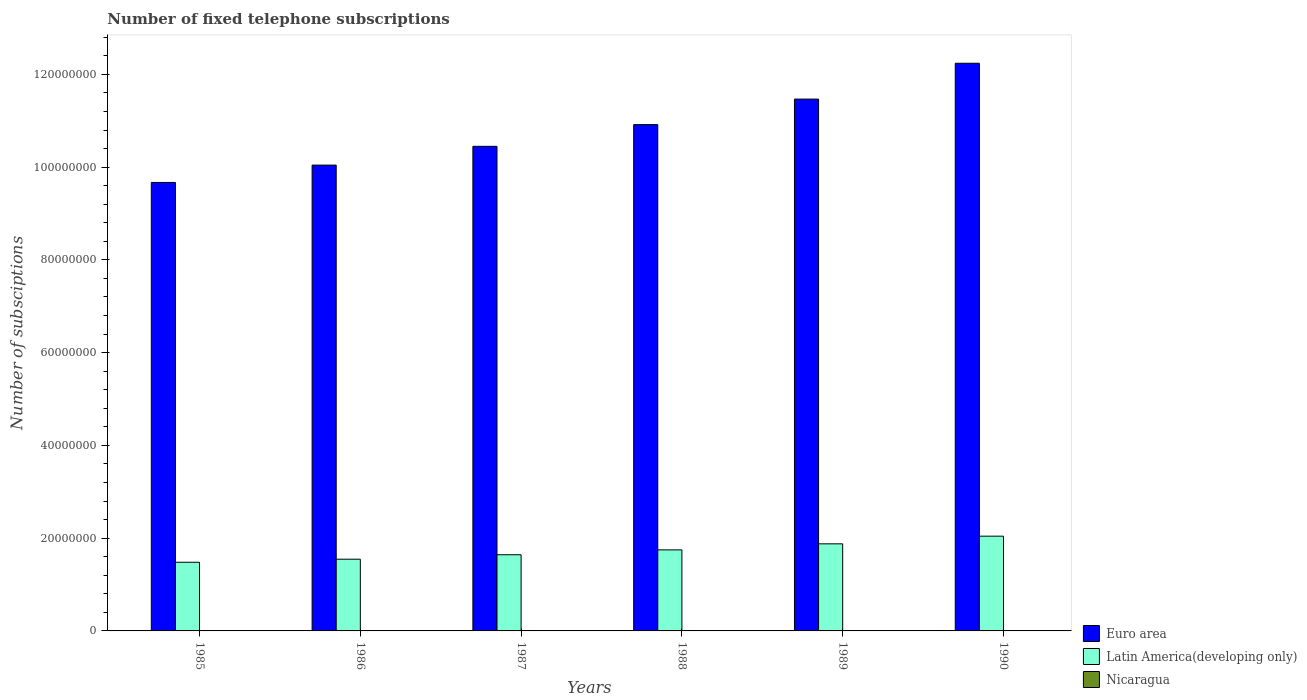How many different coloured bars are there?
Ensure brevity in your answer.  3. How many groups of bars are there?
Make the answer very short. 6. Are the number of bars per tick equal to the number of legend labels?
Your answer should be compact. Yes. How many bars are there on the 6th tick from the right?
Your answer should be very brief. 3. In how many cases, is the number of bars for a given year not equal to the number of legend labels?
Provide a succinct answer. 0. What is the number of fixed telephone subscriptions in Latin America(developing only) in 1988?
Your answer should be compact. 1.75e+07. Across all years, what is the maximum number of fixed telephone subscriptions in Euro area?
Your response must be concise. 1.22e+08. Across all years, what is the minimum number of fixed telephone subscriptions in Euro area?
Offer a very short reply. 9.67e+07. In which year was the number of fixed telephone subscriptions in Nicaragua minimum?
Give a very brief answer. 1985. What is the total number of fixed telephone subscriptions in Euro area in the graph?
Your answer should be compact. 6.48e+08. What is the difference between the number of fixed telephone subscriptions in Euro area in 1988 and that in 1990?
Keep it short and to the point. -1.32e+07. What is the difference between the number of fixed telephone subscriptions in Latin America(developing only) in 1986 and the number of fixed telephone subscriptions in Euro area in 1985?
Your answer should be very brief. -8.12e+07. What is the average number of fixed telephone subscriptions in Latin America(developing only) per year?
Your answer should be compact. 1.72e+07. In the year 1990, what is the difference between the number of fixed telephone subscriptions in Euro area and number of fixed telephone subscriptions in Latin America(developing only)?
Make the answer very short. 1.02e+08. In how many years, is the number of fixed telephone subscriptions in Latin America(developing only) greater than 48000000?
Offer a very short reply. 0. What is the ratio of the number of fixed telephone subscriptions in Nicaragua in 1985 to that in 1987?
Ensure brevity in your answer.  0.94. What is the difference between the highest and the second highest number of fixed telephone subscriptions in Nicaragua?
Give a very brief answer. 159. What is the difference between the highest and the lowest number of fixed telephone subscriptions in Latin America(developing only)?
Give a very brief answer. 5.62e+06. In how many years, is the number of fixed telephone subscriptions in Nicaragua greater than the average number of fixed telephone subscriptions in Nicaragua taken over all years?
Keep it short and to the point. 4. What does the 3rd bar from the left in 1985 represents?
Offer a very short reply. Nicaragua. What does the 2nd bar from the right in 1990 represents?
Provide a succinct answer. Latin America(developing only). Is it the case that in every year, the sum of the number of fixed telephone subscriptions in Euro area and number of fixed telephone subscriptions in Latin America(developing only) is greater than the number of fixed telephone subscriptions in Nicaragua?
Give a very brief answer. Yes. Are all the bars in the graph horizontal?
Your response must be concise. No. What is the difference between two consecutive major ticks on the Y-axis?
Keep it short and to the point. 2.00e+07. Are the values on the major ticks of Y-axis written in scientific E-notation?
Keep it short and to the point. No. Where does the legend appear in the graph?
Give a very brief answer. Bottom right. How many legend labels are there?
Ensure brevity in your answer.  3. How are the legend labels stacked?
Offer a very short reply. Vertical. What is the title of the graph?
Make the answer very short. Number of fixed telephone subscriptions. What is the label or title of the Y-axis?
Provide a short and direct response. Number of subsciptions. What is the Number of subsciptions in Euro area in 1985?
Your answer should be very brief. 9.67e+07. What is the Number of subsciptions of Latin America(developing only) in 1985?
Ensure brevity in your answer.  1.48e+07. What is the Number of subsciptions of Nicaragua in 1985?
Keep it short and to the point. 4.34e+04. What is the Number of subsciptions of Euro area in 1986?
Give a very brief answer. 1.00e+08. What is the Number of subsciptions in Latin America(developing only) in 1986?
Give a very brief answer. 1.55e+07. What is the Number of subsciptions in Nicaragua in 1986?
Offer a terse response. 4.41e+04. What is the Number of subsciptions in Euro area in 1987?
Make the answer very short. 1.04e+08. What is the Number of subsciptions of Latin America(developing only) in 1987?
Make the answer very short. 1.64e+07. What is the Number of subsciptions in Nicaragua in 1987?
Your answer should be compact. 4.59e+04. What is the Number of subsciptions of Euro area in 1988?
Ensure brevity in your answer.  1.09e+08. What is the Number of subsciptions in Latin America(developing only) in 1988?
Give a very brief answer. 1.75e+07. What is the Number of subsciptions of Nicaragua in 1988?
Keep it short and to the point. 4.55e+04. What is the Number of subsciptions of Euro area in 1989?
Provide a succinct answer. 1.15e+08. What is the Number of subsciptions of Latin America(developing only) in 1989?
Your answer should be compact. 1.88e+07. What is the Number of subsciptions in Nicaragua in 1989?
Make the answer very short. 4.62e+04. What is the Number of subsciptions of Euro area in 1990?
Your answer should be very brief. 1.22e+08. What is the Number of subsciptions of Latin America(developing only) in 1990?
Provide a short and direct response. 2.04e+07. What is the Number of subsciptions of Nicaragua in 1990?
Provide a succinct answer. 4.63e+04. Across all years, what is the maximum Number of subsciptions in Euro area?
Provide a succinct answer. 1.22e+08. Across all years, what is the maximum Number of subsciptions of Latin America(developing only)?
Keep it short and to the point. 2.04e+07. Across all years, what is the maximum Number of subsciptions in Nicaragua?
Your response must be concise. 4.63e+04. Across all years, what is the minimum Number of subsciptions of Euro area?
Give a very brief answer. 9.67e+07. Across all years, what is the minimum Number of subsciptions in Latin America(developing only)?
Provide a succinct answer. 1.48e+07. Across all years, what is the minimum Number of subsciptions of Nicaragua?
Your answer should be very brief. 4.34e+04. What is the total Number of subsciptions of Euro area in the graph?
Ensure brevity in your answer.  6.48e+08. What is the total Number of subsciptions of Latin America(developing only) in the graph?
Offer a very short reply. 1.03e+08. What is the total Number of subsciptions of Nicaragua in the graph?
Offer a terse response. 2.71e+05. What is the difference between the Number of subsciptions of Euro area in 1985 and that in 1986?
Offer a very short reply. -3.74e+06. What is the difference between the Number of subsciptions of Latin America(developing only) in 1985 and that in 1986?
Your answer should be compact. -6.58e+05. What is the difference between the Number of subsciptions of Nicaragua in 1985 and that in 1986?
Your answer should be very brief. -754. What is the difference between the Number of subsciptions of Euro area in 1985 and that in 1987?
Provide a short and direct response. -7.79e+06. What is the difference between the Number of subsciptions in Latin America(developing only) in 1985 and that in 1987?
Your answer should be compact. -1.62e+06. What is the difference between the Number of subsciptions in Nicaragua in 1985 and that in 1987?
Offer a terse response. -2557. What is the difference between the Number of subsciptions in Euro area in 1985 and that in 1988?
Your answer should be very brief. -1.25e+07. What is the difference between the Number of subsciptions of Latin America(developing only) in 1985 and that in 1988?
Keep it short and to the point. -2.67e+06. What is the difference between the Number of subsciptions of Nicaragua in 1985 and that in 1988?
Give a very brief answer. -2119. What is the difference between the Number of subsciptions in Euro area in 1985 and that in 1989?
Ensure brevity in your answer.  -1.80e+07. What is the difference between the Number of subsciptions of Latin America(developing only) in 1985 and that in 1989?
Offer a terse response. -3.97e+06. What is the difference between the Number of subsciptions of Nicaragua in 1985 and that in 1989?
Ensure brevity in your answer.  -2805. What is the difference between the Number of subsciptions in Euro area in 1985 and that in 1990?
Provide a succinct answer. -2.57e+07. What is the difference between the Number of subsciptions of Latin America(developing only) in 1985 and that in 1990?
Make the answer very short. -5.62e+06. What is the difference between the Number of subsciptions in Nicaragua in 1985 and that in 1990?
Your response must be concise. -2964. What is the difference between the Number of subsciptions of Euro area in 1986 and that in 1987?
Offer a terse response. -4.05e+06. What is the difference between the Number of subsciptions of Latin America(developing only) in 1986 and that in 1987?
Your response must be concise. -9.61e+05. What is the difference between the Number of subsciptions in Nicaragua in 1986 and that in 1987?
Provide a short and direct response. -1803. What is the difference between the Number of subsciptions of Euro area in 1986 and that in 1988?
Provide a short and direct response. -8.73e+06. What is the difference between the Number of subsciptions in Latin America(developing only) in 1986 and that in 1988?
Provide a succinct answer. -2.01e+06. What is the difference between the Number of subsciptions in Nicaragua in 1986 and that in 1988?
Your answer should be compact. -1365. What is the difference between the Number of subsciptions of Euro area in 1986 and that in 1989?
Give a very brief answer. -1.42e+07. What is the difference between the Number of subsciptions in Latin America(developing only) in 1986 and that in 1989?
Keep it short and to the point. -3.31e+06. What is the difference between the Number of subsciptions of Nicaragua in 1986 and that in 1989?
Your response must be concise. -2051. What is the difference between the Number of subsciptions in Euro area in 1986 and that in 1990?
Make the answer very short. -2.20e+07. What is the difference between the Number of subsciptions of Latin America(developing only) in 1986 and that in 1990?
Give a very brief answer. -4.97e+06. What is the difference between the Number of subsciptions of Nicaragua in 1986 and that in 1990?
Ensure brevity in your answer.  -2210. What is the difference between the Number of subsciptions in Euro area in 1987 and that in 1988?
Your answer should be very brief. -4.68e+06. What is the difference between the Number of subsciptions in Latin America(developing only) in 1987 and that in 1988?
Offer a very short reply. -1.05e+06. What is the difference between the Number of subsciptions of Nicaragua in 1987 and that in 1988?
Provide a short and direct response. 438. What is the difference between the Number of subsciptions of Euro area in 1987 and that in 1989?
Your answer should be compact. -1.02e+07. What is the difference between the Number of subsciptions of Latin America(developing only) in 1987 and that in 1989?
Your response must be concise. -2.35e+06. What is the difference between the Number of subsciptions of Nicaragua in 1987 and that in 1989?
Ensure brevity in your answer.  -248. What is the difference between the Number of subsciptions in Euro area in 1987 and that in 1990?
Provide a succinct answer. -1.79e+07. What is the difference between the Number of subsciptions of Latin America(developing only) in 1987 and that in 1990?
Offer a terse response. -4.01e+06. What is the difference between the Number of subsciptions in Nicaragua in 1987 and that in 1990?
Offer a very short reply. -407. What is the difference between the Number of subsciptions of Euro area in 1988 and that in 1989?
Offer a very short reply. -5.50e+06. What is the difference between the Number of subsciptions in Latin America(developing only) in 1988 and that in 1989?
Keep it short and to the point. -1.30e+06. What is the difference between the Number of subsciptions of Nicaragua in 1988 and that in 1989?
Keep it short and to the point. -686. What is the difference between the Number of subsciptions of Euro area in 1988 and that in 1990?
Provide a short and direct response. -1.32e+07. What is the difference between the Number of subsciptions in Latin America(developing only) in 1988 and that in 1990?
Your answer should be compact. -2.96e+06. What is the difference between the Number of subsciptions in Nicaragua in 1988 and that in 1990?
Offer a very short reply. -845. What is the difference between the Number of subsciptions in Euro area in 1989 and that in 1990?
Your answer should be very brief. -7.73e+06. What is the difference between the Number of subsciptions of Latin America(developing only) in 1989 and that in 1990?
Your answer should be very brief. -1.65e+06. What is the difference between the Number of subsciptions in Nicaragua in 1989 and that in 1990?
Provide a succinct answer. -159. What is the difference between the Number of subsciptions in Euro area in 1985 and the Number of subsciptions in Latin America(developing only) in 1986?
Make the answer very short. 8.12e+07. What is the difference between the Number of subsciptions in Euro area in 1985 and the Number of subsciptions in Nicaragua in 1986?
Provide a short and direct response. 9.67e+07. What is the difference between the Number of subsciptions in Latin America(developing only) in 1985 and the Number of subsciptions in Nicaragua in 1986?
Offer a very short reply. 1.48e+07. What is the difference between the Number of subsciptions of Euro area in 1985 and the Number of subsciptions of Latin America(developing only) in 1987?
Keep it short and to the point. 8.03e+07. What is the difference between the Number of subsciptions in Euro area in 1985 and the Number of subsciptions in Nicaragua in 1987?
Your answer should be very brief. 9.66e+07. What is the difference between the Number of subsciptions in Latin America(developing only) in 1985 and the Number of subsciptions in Nicaragua in 1987?
Make the answer very short. 1.48e+07. What is the difference between the Number of subsciptions in Euro area in 1985 and the Number of subsciptions in Latin America(developing only) in 1988?
Your response must be concise. 7.92e+07. What is the difference between the Number of subsciptions of Euro area in 1985 and the Number of subsciptions of Nicaragua in 1988?
Make the answer very short. 9.67e+07. What is the difference between the Number of subsciptions of Latin America(developing only) in 1985 and the Number of subsciptions of Nicaragua in 1988?
Your response must be concise. 1.48e+07. What is the difference between the Number of subsciptions of Euro area in 1985 and the Number of subsciptions of Latin America(developing only) in 1989?
Provide a succinct answer. 7.79e+07. What is the difference between the Number of subsciptions in Euro area in 1985 and the Number of subsciptions in Nicaragua in 1989?
Your answer should be very brief. 9.66e+07. What is the difference between the Number of subsciptions in Latin America(developing only) in 1985 and the Number of subsciptions in Nicaragua in 1989?
Offer a very short reply. 1.48e+07. What is the difference between the Number of subsciptions in Euro area in 1985 and the Number of subsciptions in Latin America(developing only) in 1990?
Make the answer very short. 7.63e+07. What is the difference between the Number of subsciptions of Euro area in 1985 and the Number of subsciptions of Nicaragua in 1990?
Provide a short and direct response. 9.66e+07. What is the difference between the Number of subsciptions in Latin America(developing only) in 1985 and the Number of subsciptions in Nicaragua in 1990?
Keep it short and to the point. 1.48e+07. What is the difference between the Number of subsciptions of Euro area in 1986 and the Number of subsciptions of Latin America(developing only) in 1987?
Offer a very short reply. 8.40e+07. What is the difference between the Number of subsciptions in Euro area in 1986 and the Number of subsciptions in Nicaragua in 1987?
Ensure brevity in your answer.  1.00e+08. What is the difference between the Number of subsciptions of Latin America(developing only) in 1986 and the Number of subsciptions of Nicaragua in 1987?
Make the answer very short. 1.54e+07. What is the difference between the Number of subsciptions in Euro area in 1986 and the Number of subsciptions in Latin America(developing only) in 1988?
Make the answer very short. 8.30e+07. What is the difference between the Number of subsciptions of Euro area in 1986 and the Number of subsciptions of Nicaragua in 1988?
Make the answer very short. 1.00e+08. What is the difference between the Number of subsciptions of Latin America(developing only) in 1986 and the Number of subsciptions of Nicaragua in 1988?
Keep it short and to the point. 1.54e+07. What is the difference between the Number of subsciptions of Euro area in 1986 and the Number of subsciptions of Latin America(developing only) in 1989?
Keep it short and to the point. 8.17e+07. What is the difference between the Number of subsciptions of Euro area in 1986 and the Number of subsciptions of Nicaragua in 1989?
Give a very brief answer. 1.00e+08. What is the difference between the Number of subsciptions of Latin America(developing only) in 1986 and the Number of subsciptions of Nicaragua in 1989?
Provide a succinct answer. 1.54e+07. What is the difference between the Number of subsciptions in Euro area in 1986 and the Number of subsciptions in Latin America(developing only) in 1990?
Your response must be concise. 8.00e+07. What is the difference between the Number of subsciptions in Euro area in 1986 and the Number of subsciptions in Nicaragua in 1990?
Make the answer very short. 1.00e+08. What is the difference between the Number of subsciptions of Latin America(developing only) in 1986 and the Number of subsciptions of Nicaragua in 1990?
Your answer should be very brief. 1.54e+07. What is the difference between the Number of subsciptions in Euro area in 1987 and the Number of subsciptions in Latin America(developing only) in 1988?
Keep it short and to the point. 8.70e+07. What is the difference between the Number of subsciptions in Euro area in 1987 and the Number of subsciptions in Nicaragua in 1988?
Give a very brief answer. 1.04e+08. What is the difference between the Number of subsciptions of Latin America(developing only) in 1987 and the Number of subsciptions of Nicaragua in 1988?
Offer a terse response. 1.64e+07. What is the difference between the Number of subsciptions of Euro area in 1987 and the Number of subsciptions of Latin America(developing only) in 1989?
Your answer should be compact. 8.57e+07. What is the difference between the Number of subsciptions in Euro area in 1987 and the Number of subsciptions in Nicaragua in 1989?
Offer a very short reply. 1.04e+08. What is the difference between the Number of subsciptions of Latin America(developing only) in 1987 and the Number of subsciptions of Nicaragua in 1989?
Provide a short and direct response. 1.64e+07. What is the difference between the Number of subsciptions of Euro area in 1987 and the Number of subsciptions of Latin America(developing only) in 1990?
Offer a very short reply. 8.41e+07. What is the difference between the Number of subsciptions in Euro area in 1987 and the Number of subsciptions in Nicaragua in 1990?
Your answer should be very brief. 1.04e+08. What is the difference between the Number of subsciptions in Latin America(developing only) in 1987 and the Number of subsciptions in Nicaragua in 1990?
Give a very brief answer. 1.64e+07. What is the difference between the Number of subsciptions in Euro area in 1988 and the Number of subsciptions in Latin America(developing only) in 1989?
Offer a terse response. 9.04e+07. What is the difference between the Number of subsciptions in Euro area in 1988 and the Number of subsciptions in Nicaragua in 1989?
Give a very brief answer. 1.09e+08. What is the difference between the Number of subsciptions in Latin America(developing only) in 1988 and the Number of subsciptions in Nicaragua in 1989?
Make the answer very short. 1.74e+07. What is the difference between the Number of subsciptions of Euro area in 1988 and the Number of subsciptions of Latin America(developing only) in 1990?
Your answer should be very brief. 8.87e+07. What is the difference between the Number of subsciptions in Euro area in 1988 and the Number of subsciptions in Nicaragua in 1990?
Give a very brief answer. 1.09e+08. What is the difference between the Number of subsciptions of Latin America(developing only) in 1988 and the Number of subsciptions of Nicaragua in 1990?
Give a very brief answer. 1.74e+07. What is the difference between the Number of subsciptions in Euro area in 1989 and the Number of subsciptions in Latin America(developing only) in 1990?
Your response must be concise. 9.42e+07. What is the difference between the Number of subsciptions in Euro area in 1989 and the Number of subsciptions in Nicaragua in 1990?
Ensure brevity in your answer.  1.15e+08. What is the difference between the Number of subsciptions of Latin America(developing only) in 1989 and the Number of subsciptions of Nicaragua in 1990?
Keep it short and to the point. 1.87e+07. What is the average Number of subsciptions in Euro area per year?
Make the answer very short. 1.08e+08. What is the average Number of subsciptions in Latin America(developing only) per year?
Keep it short and to the point. 1.72e+07. What is the average Number of subsciptions in Nicaragua per year?
Offer a very short reply. 4.52e+04. In the year 1985, what is the difference between the Number of subsciptions in Euro area and Number of subsciptions in Latin America(developing only)?
Your answer should be compact. 8.19e+07. In the year 1985, what is the difference between the Number of subsciptions of Euro area and Number of subsciptions of Nicaragua?
Your answer should be very brief. 9.67e+07. In the year 1985, what is the difference between the Number of subsciptions of Latin America(developing only) and Number of subsciptions of Nicaragua?
Provide a short and direct response. 1.48e+07. In the year 1986, what is the difference between the Number of subsciptions of Euro area and Number of subsciptions of Latin America(developing only)?
Keep it short and to the point. 8.50e+07. In the year 1986, what is the difference between the Number of subsciptions in Euro area and Number of subsciptions in Nicaragua?
Provide a short and direct response. 1.00e+08. In the year 1986, what is the difference between the Number of subsciptions in Latin America(developing only) and Number of subsciptions in Nicaragua?
Provide a short and direct response. 1.54e+07. In the year 1987, what is the difference between the Number of subsciptions of Euro area and Number of subsciptions of Latin America(developing only)?
Provide a short and direct response. 8.81e+07. In the year 1987, what is the difference between the Number of subsciptions of Euro area and Number of subsciptions of Nicaragua?
Your answer should be compact. 1.04e+08. In the year 1987, what is the difference between the Number of subsciptions in Latin America(developing only) and Number of subsciptions in Nicaragua?
Ensure brevity in your answer.  1.64e+07. In the year 1988, what is the difference between the Number of subsciptions in Euro area and Number of subsciptions in Latin America(developing only)?
Offer a very short reply. 9.17e+07. In the year 1988, what is the difference between the Number of subsciptions of Euro area and Number of subsciptions of Nicaragua?
Your response must be concise. 1.09e+08. In the year 1988, what is the difference between the Number of subsciptions in Latin America(developing only) and Number of subsciptions in Nicaragua?
Make the answer very short. 1.74e+07. In the year 1989, what is the difference between the Number of subsciptions of Euro area and Number of subsciptions of Latin America(developing only)?
Offer a very short reply. 9.59e+07. In the year 1989, what is the difference between the Number of subsciptions in Euro area and Number of subsciptions in Nicaragua?
Provide a short and direct response. 1.15e+08. In the year 1989, what is the difference between the Number of subsciptions of Latin America(developing only) and Number of subsciptions of Nicaragua?
Your response must be concise. 1.87e+07. In the year 1990, what is the difference between the Number of subsciptions in Euro area and Number of subsciptions in Latin America(developing only)?
Your answer should be compact. 1.02e+08. In the year 1990, what is the difference between the Number of subsciptions in Euro area and Number of subsciptions in Nicaragua?
Give a very brief answer. 1.22e+08. In the year 1990, what is the difference between the Number of subsciptions in Latin America(developing only) and Number of subsciptions in Nicaragua?
Ensure brevity in your answer.  2.04e+07. What is the ratio of the Number of subsciptions of Euro area in 1985 to that in 1986?
Offer a terse response. 0.96. What is the ratio of the Number of subsciptions of Latin America(developing only) in 1985 to that in 1986?
Your answer should be very brief. 0.96. What is the ratio of the Number of subsciptions of Nicaragua in 1985 to that in 1986?
Your response must be concise. 0.98. What is the ratio of the Number of subsciptions of Euro area in 1985 to that in 1987?
Your response must be concise. 0.93. What is the ratio of the Number of subsciptions of Latin America(developing only) in 1985 to that in 1987?
Provide a succinct answer. 0.9. What is the ratio of the Number of subsciptions of Nicaragua in 1985 to that in 1987?
Provide a succinct answer. 0.94. What is the ratio of the Number of subsciptions of Euro area in 1985 to that in 1988?
Ensure brevity in your answer.  0.89. What is the ratio of the Number of subsciptions of Latin America(developing only) in 1985 to that in 1988?
Keep it short and to the point. 0.85. What is the ratio of the Number of subsciptions of Nicaragua in 1985 to that in 1988?
Offer a terse response. 0.95. What is the ratio of the Number of subsciptions of Euro area in 1985 to that in 1989?
Offer a terse response. 0.84. What is the ratio of the Number of subsciptions of Latin America(developing only) in 1985 to that in 1989?
Ensure brevity in your answer.  0.79. What is the ratio of the Number of subsciptions of Nicaragua in 1985 to that in 1989?
Offer a very short reply. 0.94. What is the ratio of the Number of subsciptions in Euro area in 1985 to that in 1990?
Provide a succinct answer. 0.79. What is the ratio of the Number of subsciptions of Latin America(developing only) in 1985 to that in 1990?
Offer a terse response. 0.72. What is the ratio of the Number of subsciptions of Nicaragua in 1985 to that in 1990?
Provide a short and direct response. 0.94. What is the ratio of the Number of subsciptions in Euro area in 1986 to that in 1987?
Provide a short and direct response. 0.96. What is the ratio of the Number of subsciptions of Latin America(developing only) in 1986 to that in 1987?
Offer a very short reply. 0.94. What is the ratio of the Number of subsciptions of Nicaragua in 1986 to that in 1987?
Give a very brief answer. 0.96. What is the ratio of the Number of subsciptions of Latin America(developing only) in 1986 to that in 1988?
Keep it short and to the point. 0.89. What is the ratio of the Number of subsciptions of Euro area in 1986 to that in 1989?
Your answer should be compact. 0.88. What is the ratio of the Number of subsciptions of Latin America(developing only) in 1986 to that in 1989?
Your answer should be compact. 0.82. What is the ratio of the Number of subsciptions in Nicaragua in 1986 to that in 1989?
Your response must be concise. 0.96. What is the ratio of the Number of subsciptions of Euro area in 1986 to that in 1990?
Give a very brief answer. 0.82. What is the ratio of the Number of subsciptions in Latin America(developing only) in 1986 to that in 1990?
Ensure brevity in your answer.  0.76. What is the ratio of the Number of subsciptions of Nicaragua in 1986 to that in 1990?
Keep it short and to the point. 0.95. What is the ratio of the Number of subsciptions in Euro area in 1987 to that in 1988?
Make the answer very short. 0.96. What is the ratio of the Number of subsciptions of Latin America(developing only) in 1987 to that in 1988?
Keep it short and to the point. 0.94. What is the ratio of the Number of subsciptions in Nicaragua in 1987 to that in 1988?
Make the answer very short. 1.01. What is the ratio of the Number of subsciptions in Euro area in 1987 to that in 1989?
Offer a terse response. 0.91. What is the ratio of the Number of subsciptions in Latin America(developing only) in 1987 to that in 1989?
Your response must be concise. 0.87. What is the ratio of the Number of subsciptions in Euro area in 1987 to that in 1990?
Your answer should be very brief. 0.85. What is the ratio of the Number of subsciptions in Latin America(developing only) in 1987 to that in 1990?
Provide a succinct answer. 0.8. What is the ratio of the Number of subsciptions in Nicaragua in 1987 to that in 1990?
Offer a very short reply. 0.99. What is the ratio of the Number of subsciptions in Euro area in 1988 to that in 1989?
Keep it short and to the point. 0.95. What is the ratio of the Number of subsciptions in Latin America(developing only) in 1988 to that in 1989?
Keep it short and to the point. 0.93. What is the ratio of the Number of subsciptions in Nicaragua in 1988 to that in 1989?
Provide a succinct answer. 0.99. What is the ratio of the Number of subsciptions of Euro area in 1988 to that in 1990?
Give a very brief answer. 0.89. What is the ratio of the Number of subsciptions of Latin America(developing only) in 1988 to that in 1990?
Offer a very short reply. 0.86. What is the ratio of the Number of subsciptions in Nicaragua in 1988 to that in 1990?
Offer a terse response. 0.98. What is the ratio of the Number of subsciptions of Euro area in 1989 to that in 1990?
Offer a very short reply. 0.94. What is the ratio of the Number of subsciptions of Latin America(developing only) in 1989 to that in 1990?
Ensure brevity in your answer.  0.92. What is the ratio of the Number of subsciptions of Nicaragua in 1989 to that in 1990?
Make the answer very short. 1. What is the difference between the highest and the second highest Number of subsciptions of Euro area?
Offer a terse response. 7.73e+06. What is the difference between the highest and the second highest Number of subsciptions of Latin America(developing only)?
Keep it short and to the point. 1.65e+06. What is the difference between the highest and the second highest Number of subsciptions in Nicaragua?
Offer a very short reply. 159. What is the difference between the highest and the lowest Number of subsciptions in Euro area?
Provide a succinct answer. 2.57e+07. What is the difference between the highest and the lowest Number of subsciptions of Latin America(developing only)?
Keep it short and to the point. 5.62e+06. What is the difference between the highest and the lowest Number of subsciptions of Nicaragua?
Make the answer very short. 2964. 